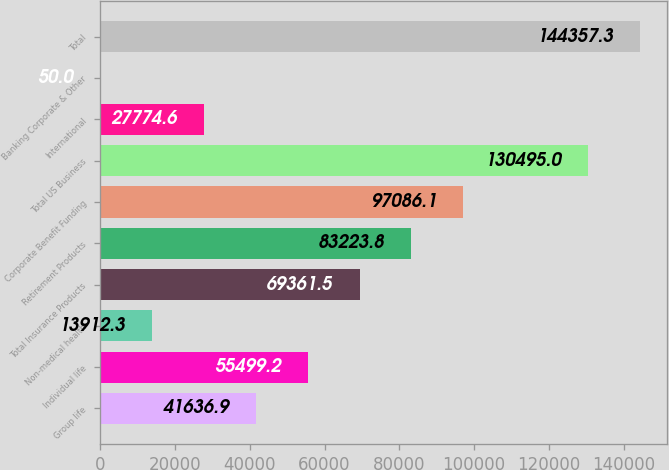Convert chart. <chart><loc_0><loc_0><loc_500><loc_500><bar_chart><fcel>Group life<fcel>Individual life<fcel>Non-medical health<fcel>Total Insurance Products<fcel>Retirement Products<fcel>Corporate Benefit Funding<fcel>Total US Business<fcel>International<fcel>Banking Corporate & Other<fcel>Total<nl><fcel>41636.9<fcel>55499.2<fcel>13912.3<fcel>69361.5<fcel>83223.8<fcel>97086.1<fcel>130495<fcel>27774.6<fcel>50<fcel>144357<nl></chart> 